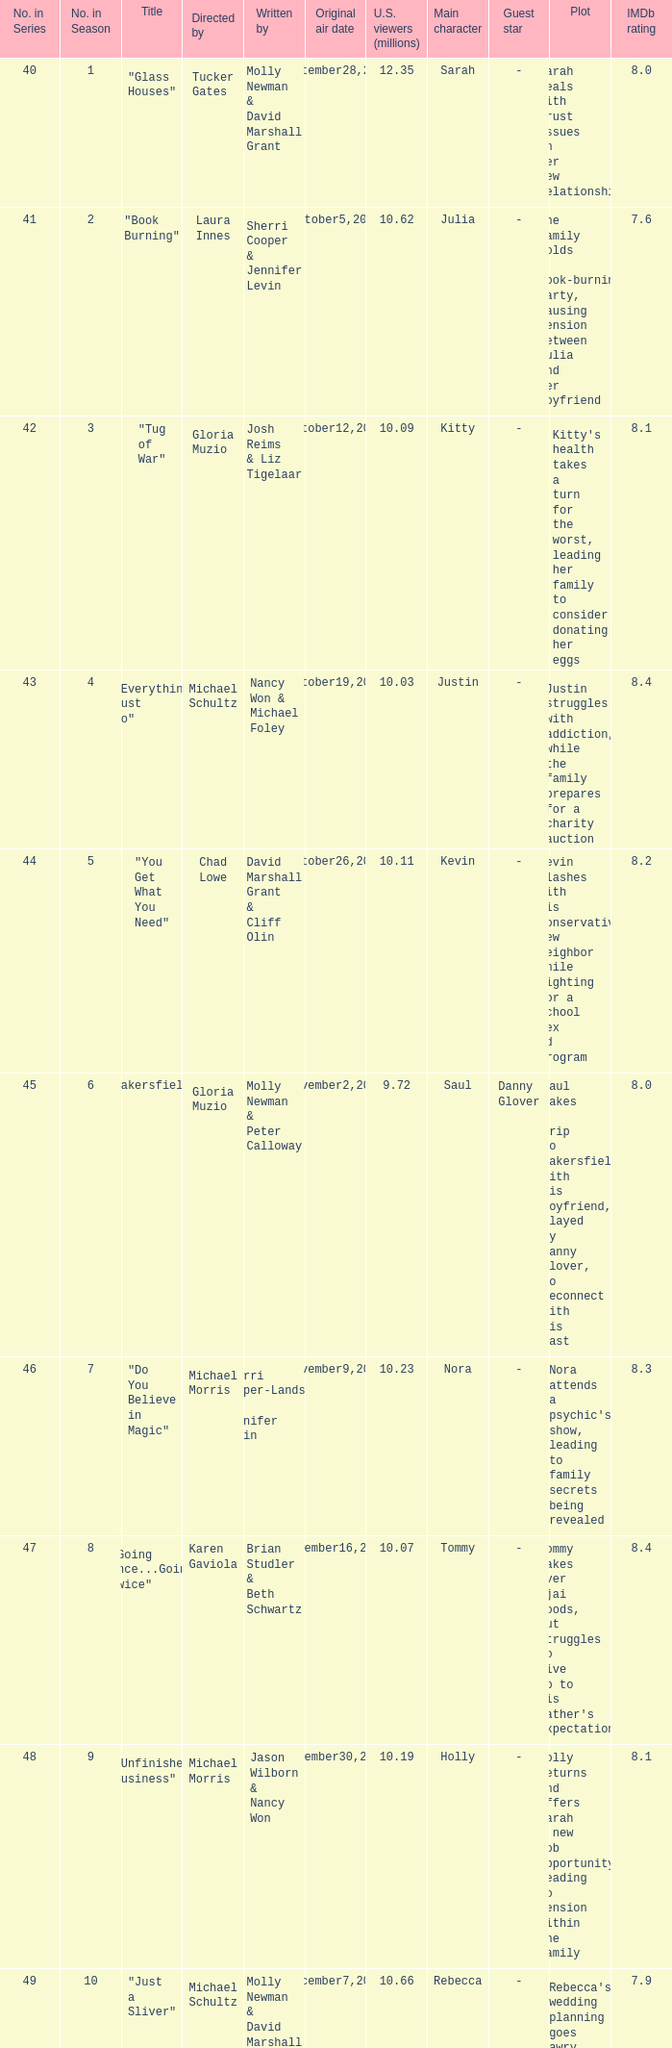Who wrote the episode whose director is Karen Gaviola? Brian Studler & Beth Schwartz. 